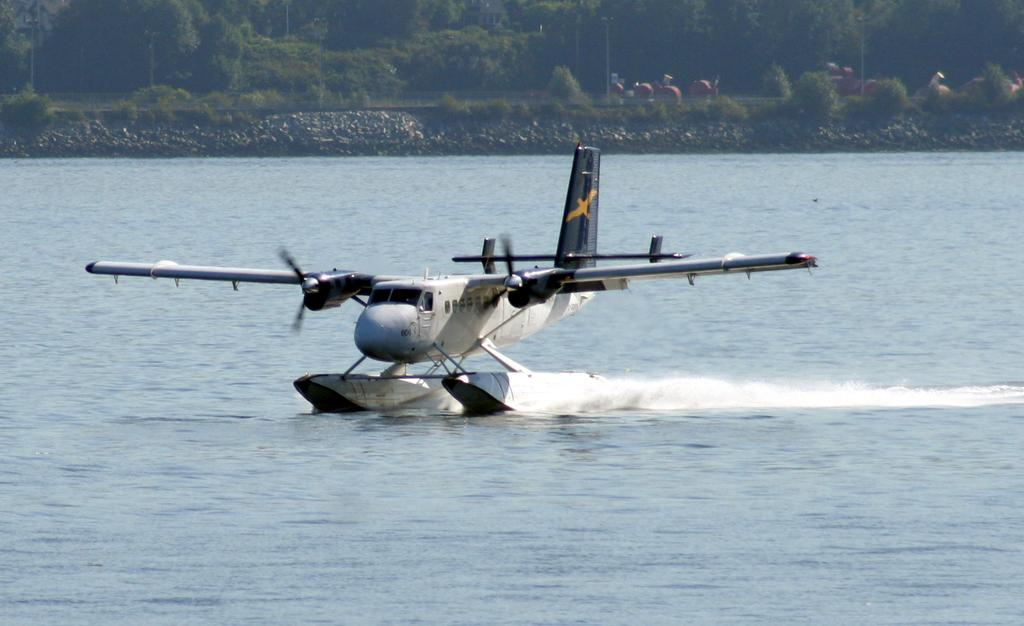What type of vehicle is in the image? There is a seaplane in the image. Where is the seaplane located? The seaplane is on the water. What can be seen in the background of the image? There are trees in the background of the image. What type of print can be seen on the fireman's uniform in the image? There is no fireman or uniform present in the image; it features a seaplane on the water with trees in the background. 